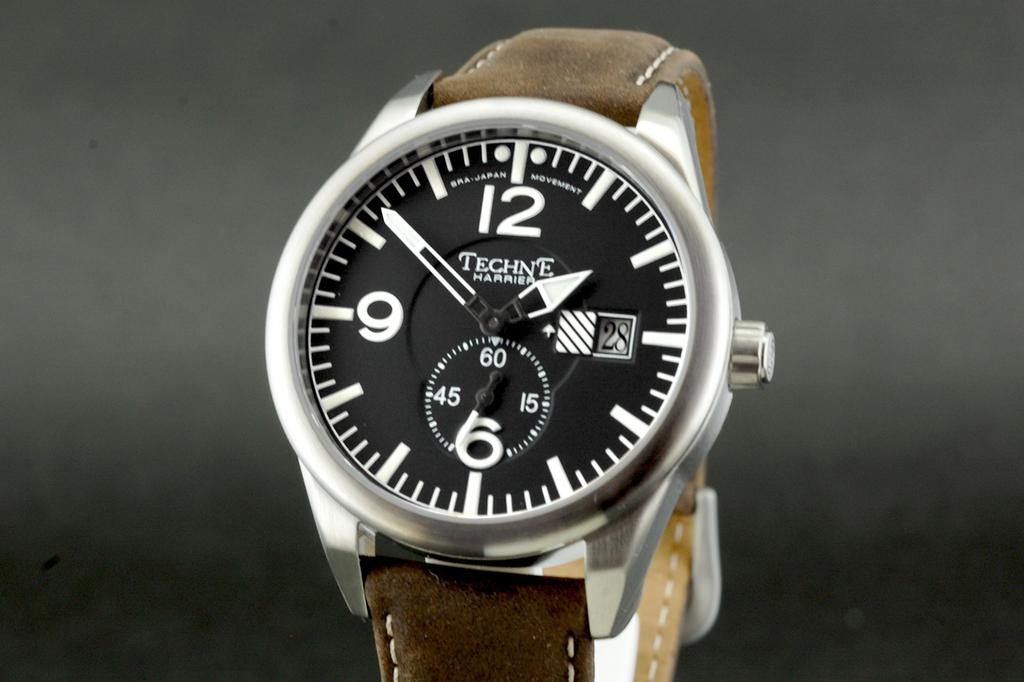<image>
Share a concise interpretation of the image provided. A Techne Harrier wrist watch with a brown band, shows the time as 1:51. 